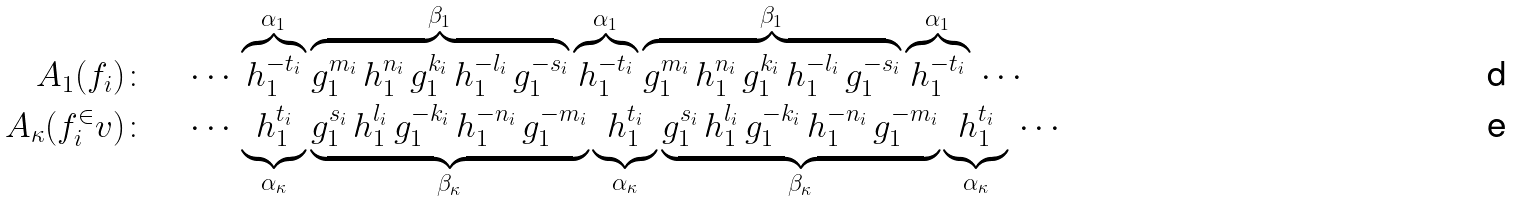<formula> <loc_0><loc_0><loc_500><loc_500>A _ { 1 } ( f _ { i } ) \colon \quad & \cdots \, \overbrace { h _ { 1 } ^ { - t _ { i } } } ^ { \alpha _ { 1 } } \overbrace { g _ { 1 } ^ { m _ { i } } \, h _ { 1 } ^ { n _ { i } } \, g _ { 1 } ^ { k _ { i } } \, h _ { 1 } ^ { - l _ { i } } \, g _ { 1 } ^ { - s _ { i } } } ^ { \beta _ { 1 } } \overbrace { h _ { 1 } ^ { - t _ { i } } } ^ { \alpha _ { 1 } } \overbrace { g _ { 1 } ^ { m _ { i } } \, h _ { 1 } ^ { n _ { i } } \, g _ { 1 } ^ { k _ { i } } \, h _ { 1 } ^ { - l _ { i } } \, g _ { 1 } ^ { - s _ { i } } } ^ { \beta _ { 1 } } \overbrace { h _ { 1 } ^ { - t _ { i } } } ^ { \alpha _ { 1 } } \, \cdots \\ A _ { \kappa } ( f _ { i } ^ { \in } v ) \colon \quad & \cdots \, \underbrace { h _ { 1 } ^ { t _ { i } } } _ { \alpha _ { \kappa } } \underbrace { g _ { 1 } ^ { s _ { i } } \, h _ { 1 } ^ { l _ { i } } \, g _ { 1 } ^ { - k _ { i } } \, h _ { 1 } ^ { - n _ { i } } \, g _ { 1 } ^ { - m _ { i } } } _ { \beta _ { \kappa } } \underbrace { h _ { 1 } ^ { t _ { i } } } _ { \alpha _ { \kappa } } \underbrace { g _ { 1 } ^ { s _ { i } } \, h _ { 1 } ^ { l _ { i } } \, g _ { 1 } ^ { - k _ { i } } \, h _ { 1 } ^ { - n _ { i } } \, g _ { 1 } ^ { - m _ { i } } } _ { \beta _ { \kappa } } \underbrace { h _ { 1 } ^ { t _ { i } } } _ { \alpha _ { \kappa } } \, \cdots</formula> 